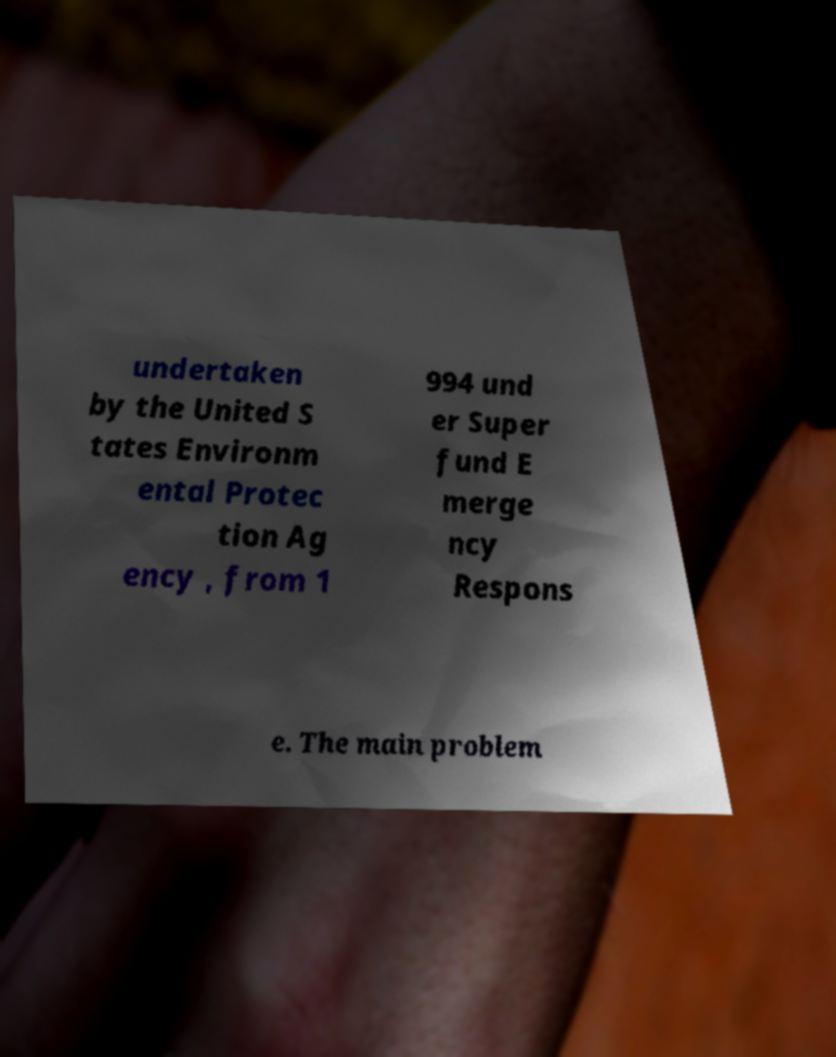What messages or text are displayed in this image? I need them in a readable, typed format. undertaken by the United S tates Environm ental Protec tion Ag ency , from 1 994 und er Super fund E merge ncy Respons e. The main problem 